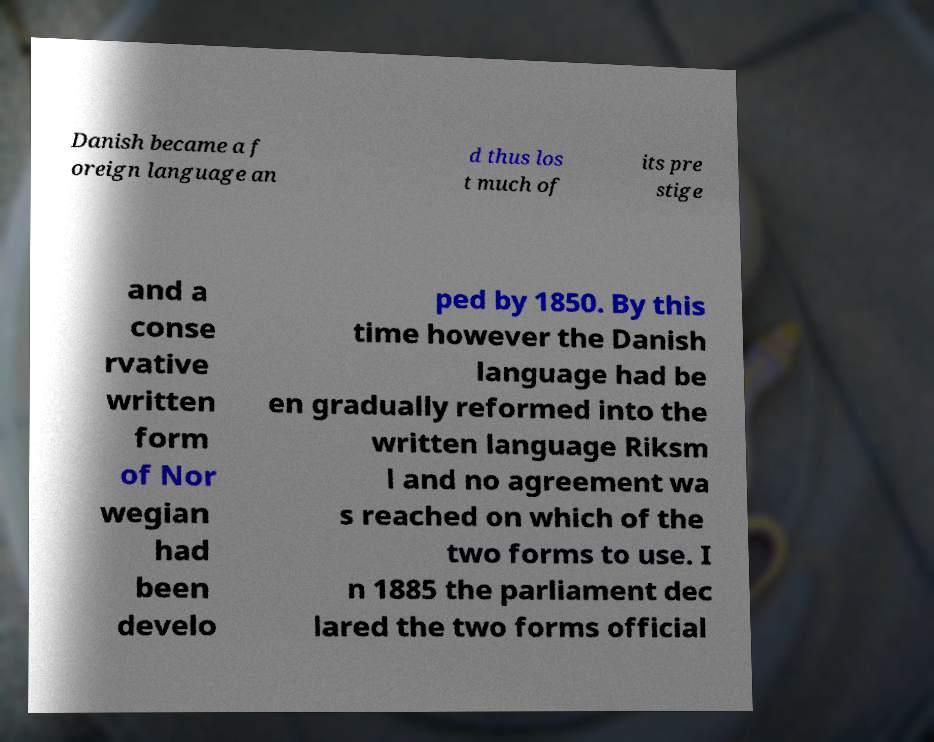There's text embedded in this image that I need extracted. Can you transcribe it verbatim? Danish became a f oreign language an d thus los t much of its pre stige and a conse rvative written form of Nor wegian had been develo ped by 1850. By this time however the Danish language had be en gradually reformed into the written language Riksm l and no agreement wa s reached on which of the two forms to use. I n 1885 the parliament dec lared the two forms official 